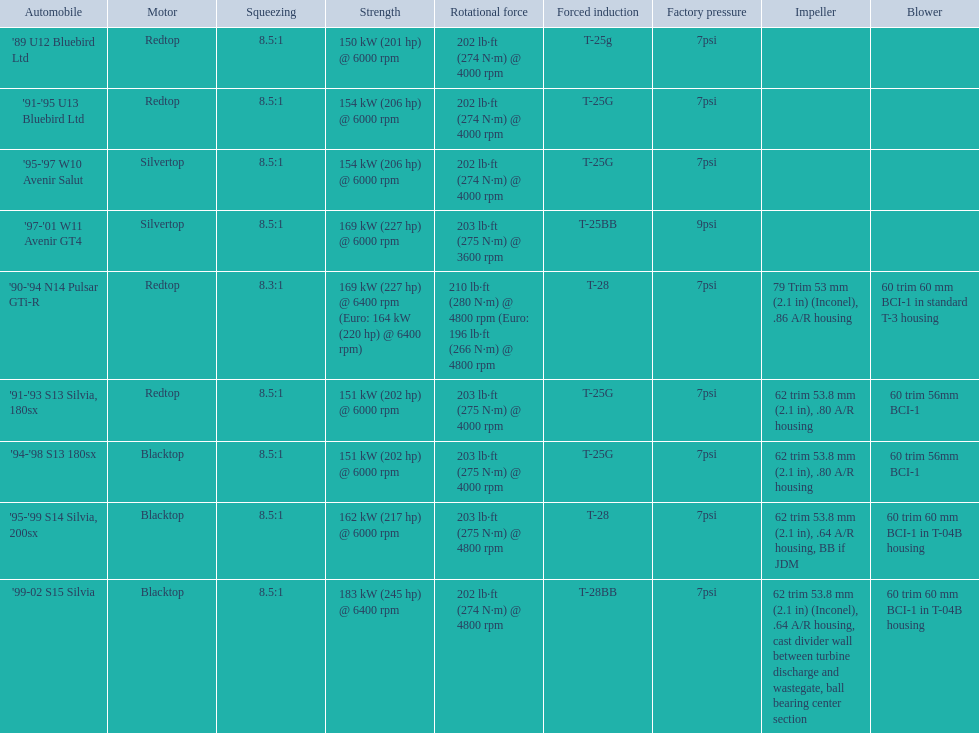Which cars featured blacktop engines? '94-'98 S13 180sx, '95-'99 S14 Silvia, 200sx, '99-02 S15 Silvia. Which of these had t-04b compressor housings? '95-'99 S14 Silvia, 200sx, '99-02 S15 Silvia. Which one of these has the highest horsepower? '99-02 S15 Silvia. 